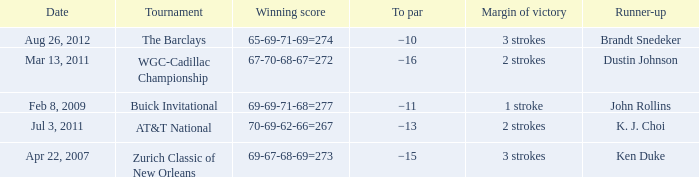What was the to par of the tournament that had Ken Duke as a runner-up? −15. 